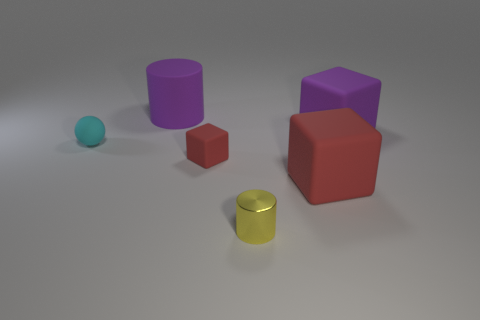Add 4 large brown metallic cylinders. How many objects exist? 10 Subtract all balls. How many objects are left? 5 Add 1 cylinders. How many cylinders are left? 3 Add 2 big matte cylinders. How many big matte cylinders exist? 3 Subtract 0 gray spheres. How many objects are left? 6 Subtract all small metal cylinders. Subtract all big metallic cubes. How many objects are left? 5 